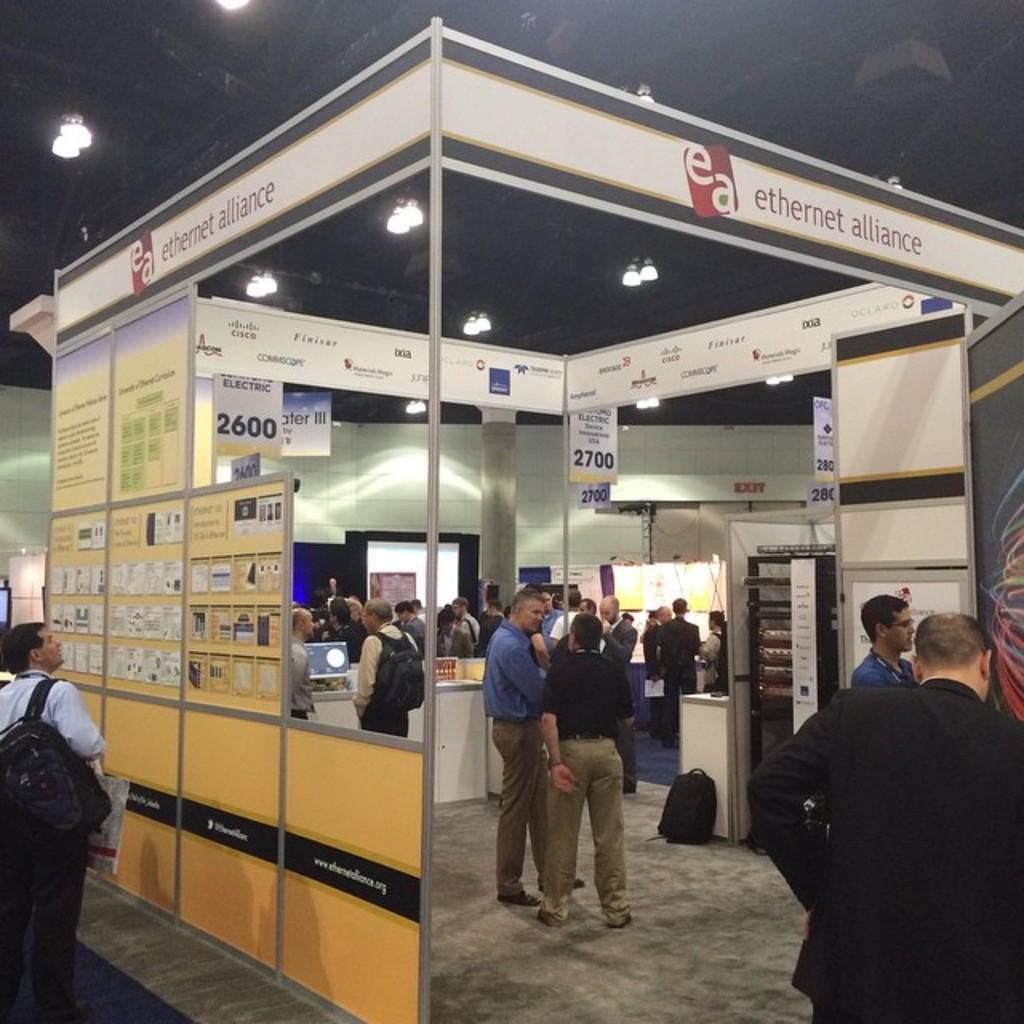What type of structure is present in the image? There is a stall in the image. How many people are inside the stall? There are many people inside the stall. What can be seen hanging inside the stall? There are different banners inside the stall. What are the counters used for inside the stall? The counters are used for various purposes inside the stall. What is visible in the background of the image? There is an exit board in the background of the image. What type of loaf is being sold at the stall in the image? There is no loaf present in the image; it is a stall with banners and counters. Can you tell me how many credit cards are being used by the people inside the stall? There is no mention of credit cards being used in the image. What is the main purpose of the stall in the image? The stall in the image appears to be a place where people are gathered and banners and counters are present. Are there any bikes visible in the image? There are no bikes present in the image; it is a stall with people, banners, and counters. What type of exit board is visible in the background of the image? The exit board in the background of the image is not described in detail, but it is visible. Reasoning: Let's think step by step in order to produce the conversation. We start by identifying the main structure in the image, which is the stall. Then, we describe the people and objects inside the stall, such as the banners and counters. Finally, we mention the exit board visible in the background. Each question is designed to elicit a specific detail about the image that is known from the provided facts. Absurd Question/Answer: What type of bike is being ridden by the person in the image? There is no person or bike present in the image; it is a stall with people, banners, and counters. 